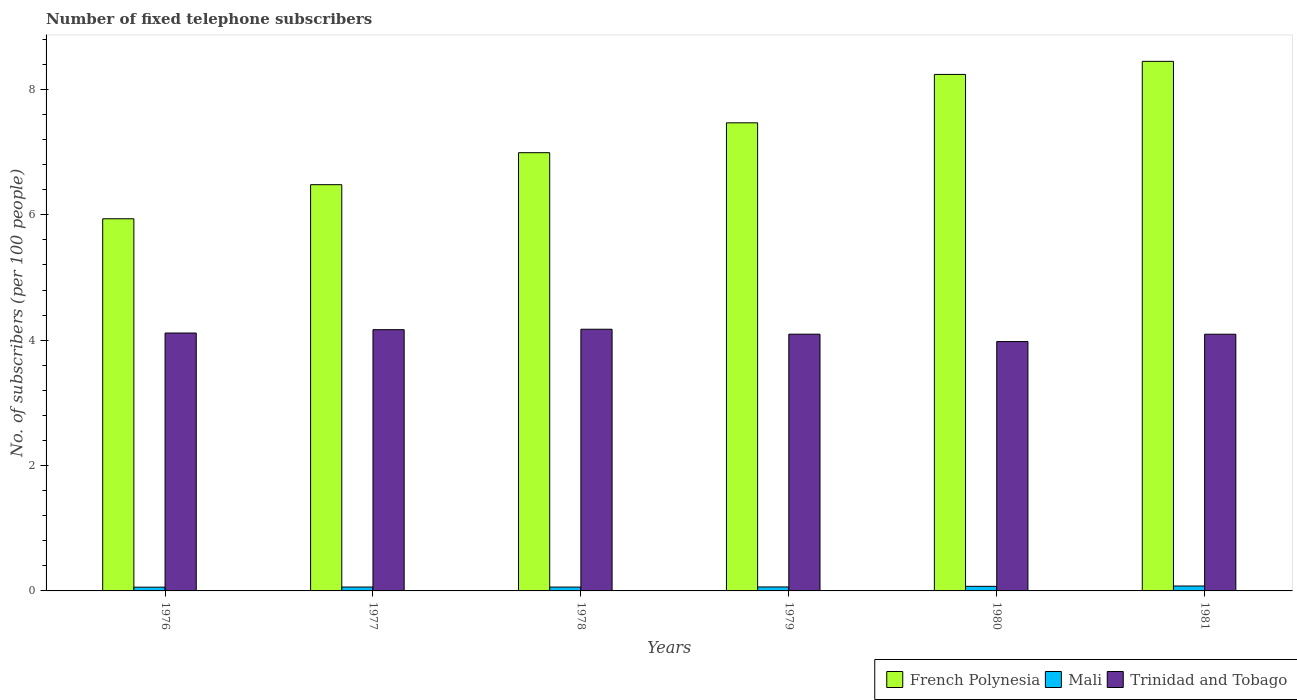How many groups of bars are there?
Your answer should be compact. 6. Are the number of bars per tick equal to the number of legend labels?
Offer a very short reply. Yes. How many bars are there on the 3rd tick from the left?
Offer a terse response. 3. What is the number of fixed telephone subscribers in Trinidad and Tobago in 1976?
Offer a very short reply. 4.11. Across all years, what is the maximum number of fixed telephone subscribers in Trinidad and Tobago?
Provide a short and direct response. 4.17. Across all years, what is the minimum number of fixed telephone subscribers in Trinidad and Tobago?
Ensure brevity in your answer.  3.98. In which year was the number of fixed telephone subscribers in French Polynesia maximum?
Provide a short and direct response. 1981. In which year was the number of fixed telephone subscribers in Mali minimum?
Give a very brief answer. 1976. What is the total number of fixed telephone subscribers in Mali in the graph?
Offer a very short reply. 0.4. What is the difference between the number of fixed telephone subscribers in French Polynesia in 1978 and that in 1979?
Offer a terse response. -0.48. What is the difference between the number of fixed telephone subscribers in Trinidad and Tobago in 1976 and the number of fixed telephone subscribers in Mali in 1980?
Provide a succinct answer. 4.04. What is the average number of fixed telephone subscribers in Trinidad and Tobago per year?
Provide a short and direct response. 4.1. In the year 1976, what is the difference between the number of fixed telephone subscribers in Trinidad and Tobago and number of fixed telephone subscribers in Mali?
Keep it short and to the point. 4.05. What is the ratio of the number of fixed telephone subscribers in Mali in 1979 to that in 1980?
Ensure brevity in your answer.  0.87. What is the difference between the highest and the second highest number of fixed telephone subscribers in Mali?
Offer a very short reply. 0.01. What is the difference between the highest and the lowest number of fixed telephone subscribers in French Polynesia?
Keep it short and to the point. 2.51. In how many years, is the number of fixed telephone subscribers in Mali greater than the average number of fixed telephone subscribers in Mali taken over all years?
Your answer should be very brief. 2. What does the 1st bar from the left in 1976 represents?
Your answer should be compact. French Polynesia. What does the 3rd bar from the right in 1977 represents?
Your response must be concise. French Polynesia. How many years are there in the graph?
Give a very brief answer. 6. Are the values on the major ticks of Y-axis written in scientific E-notation?
Offer a terse response. No. Where does the legend appear in the graph?
Provide a succinct answer. Bottom right. How are the legend labels stacked?
Give a very brief answer. Horizontal. What is the title of the graph?
Ensure brevity in your answer.  Number of fixed telephone subscribers. What is the label or title of the X-axis?
Your answer should be compact. Years. What is the label or title of the Y-axis?
Give a very brief answer. No. of subscribers (per 100 people). What is the No. of subscribers (per 100 people) of French Polynesia in 1976?
Provide a succinct answer. 5.94. What is the No. of subscribers (per 100 people) of Mali in 1976?
Provide a succinct answer. 0.06. What is the No. of subscribers (per 100 people) of Trinidad and Tobago in 1976?
Give a very brief answer. 4.11. What is the No. of subscribers (per 100 people) in French Polynesia in 1977?
Your answer should be compact. 6.48. What is the No. of subscribers (per 100 people) of Mali in 1977?
Your response must be concise. 0.06. What is the No. of subscribers (per 100 people) in Trinidad and Tobago in 1977?
Give a very brief answer. 4.17. What is the No. of subscribers (per 100 people) in French Polynesia in 1978?
Provide a short and direct response. 6.99. What is the No. of subscribers (per 100 people) of Mali in 1978?
Keep it short and to the point. 0.06. What is the No. of subscribers (per 100 people) of Trinidad and Tobago in 1978?
Give a very brief answer. 4.17. What is the No. of subscribers (per 100 people) in French Polynesia in 1979?
Your answer should be compact. 7.47. What is the No. of subscribers (per 100 people) in Mali in 1979?
Make the answer very short. 0.06. What is the No. of subscribers (per 100 people) in Trinidad and Tobago in 1979?
Offer a very short reply. 4.1. What is the No. of subscribers (per 100 people) in French Polynesia in 1980?
Your response must be concise. 8.24. What is the No. of subscribers (per 100 people) of Mali in 1980?
Make the answer very short. 0.07. What is the No. of subscribers (per 100 people) in Trinidad and Tobago in 1980?
Provide a short and direct response. 3.98. What is the No. of subscribers (per 100 people) in French Polynesia in 1981?
Make the answer very short. 8.45. What is the No. of subscribers (per 100 people) in Mali in 1981?
Your response must be concise. 0.08. What is the No. of subscribers (per 100 people) in Trinidad and Tobago in 1981?
Your answer should be very brief. 4.1. Across all years, what is the maximum No. of subscribers (per 100 people) in French Polynesia?
Provide a succinct answer. 8.45. Across all years, what is the maximum No. of subscribers (per 100 people) in Mali?
Provide a succinct answer. 0.08. Across all years, what is the maximum No. of subscribers (per 100 people) of Trinidad and Tobago?
Your answer should be compact. 4.17. Across all years, what is the minimum No. of subscribers (per 100 people) of French Polynesia?
Your response must be concise. 5.94. Across all years, what is the minimum No. of subscribers (per 100 people) of Mali?
Your answer should be compact. 0.06. Across all years, what is the minimum No. of subscribers (per 100 people) of Trinidad and Tobago?
Offer a very short reply. 3.98. What is the total No. of subscribers (per 100 people) of French Polynesia in the graph?
Your answer should be very brief. 43.57. What is the total No. of subscribers (per 100 people) of Mali in the graph?
Your response must be concise. 0.4. What is the total No. of subscribers (per 100 people) of Trinidad and Tobago in the graph?
Give a very brief answer. 24.63. What is the difference between the No. of subscribers (per 100 people) in French Polynesia in 1976 and that in 1977?
Ensure brevity in your answer.  -0.54. What is the difference between the No. of subscribers (per 100 people) of Mali in 1976 and that in 1977?
Offer a very short reply. -0. What is the difference between the No. of subscribers (per 100 people) in Trinidad and Tobago in 1976 and that in 1977?
Your answer should be compact. -0.05. What is the difference between the No. of subscribers (per 100 people) of French Polynesia in 1976 and that in 1978?
Keep it short and to the point. -1.05. What is the difference between the No. of subscribers (per 100 people) of Mali in 1976 and that in 1978?
Offer a terse response. -0. What is the difference between the No. of subscribers (per 100 people) of Trinidad and Tobago in 1976 and that in 1978?
Offer a very short reply. -0.06. What is the difference between the No. of subscribers (per 100 people) of French Polynesia in 1976 and that in 1979?
Provide a short and direct response. -1.53. What is the difference between the No. of subscribers (per 100 people) in Mali in 1976 and that in 1979?
Your answer should be very brief. -0. What is the difference between the No. of subscribers (per 100 people) in Trinidad and Tobago in 1976 and that in 1979?
Your answer should be very brief. 0.02. What is the difference between the No. of subscribers (per 100 people) of French Polynesia in 1976 and that in 1980?
Provide a short and direct response. -2.3. What is the difference between the No. of subscribers (per 100 people) in Mali in 1976 and that in 1980?
Make the answer very short. -0.01. What is the difference between the No. of subscribers (per 100 people) in Trinidad and Tobago in 1976 and that in 1980?
Your response must be concise. 0.14. What is the difference between the No. of subscribers (per 100 people) in French Polynesia in 1976 and that in 1981?
Provide a succinct answer. -2.51. What is the difference between the No. of subscribers (per 100 people) of Mali in 1976 and that in 1981?
Give a very brief answer. -0.02. What is the difference between the No. of subscribers (per 100 people) of Trinidad and Tobago in 1976 and that in 1981?
Your answer should be compact. 0.02. What is the difference between the No. of subscribers (per 100 people) in French Polynesia in 1977 and that in 1978?
Offer a very short reply. -0.51. What is the difference between the No. of subscribers (per 100 people) in Mali in 1977 and that in 1978?
Give a very brief answer. 0. What is the difference between the No. of subscribers (per 100 people) in Trinidad and Tobago in 1977 and that in 1978?
Offer a very short reply. -0.01. What is the difference between the No. of subscribers (per 100 people) in French Polynesia in 1977 and that in 1979?
Make the answer very short. -0.99. What is the difference between the No. of subscribers (per 100 people) in Mali in 1977 and that in 1979?
Provide a succinct answer. -0. What is the difference between the No. of subscribers (per 100 people) of Trinidad and Tobago in 1977 and that in 1979?
Offer a very short reply. 0.07. What is the difference between the No. of subscribers (per 100 people) in French Polynesia in 1977 and that in 1980?
Your answer should be very brief. -1.76. What is the difference between the No. of subscribers (per 100 people) in Mali in 1977 and that in 1980?
Your answer should be compact. -0.01. What is the difference between the No. of subscribers (per 100 people) of Trinidad and Tobago in 1977 and that in 1980?
Provide a short and direct response. 0.19. What is the difference between the No. of subscribers (per 100 people) in French Polynesia in 1977 and that in 1981?
Offer a terse response. -1.97. What is the difference between the No. of subscribers (per 100 people) of Mali in 1977 and that in 1981?
Keep it short and to the point. -0.02. What is the difference between the No. of subscribers (per 100 people) in Trinidad and Tobago in 1977 and that in 1981?
Offer a very short reply. 0.07. What is the difference between the No. of subscribers (per 100 people) of French Polynesia in 1978 and that in 1979?
Give a very brief answer. -0.48. What is the difference between the No. of subscribers (per 100 people) in Mali in 1978 and that in 1979?
Your response must be concise. -0. What is the difference between the No. of subscribers (per 100 people) of Trinidad and Tobago in 1978 and that in 1979?
Offer a terse response. 0.08. What is the difference between the No. of subscribers (per 100 people) of French Polynesia in 1978 and that in 1980?
Your answer should be compact. -1.25. What is the difference between the No. of subscribers (per 100 people) of Mali in 1978 and that in 1980?
Offer a terse response. -0.01. What is the difference between the No. of subscribers (per 100 people) in Trinidad and Tobago in 1978 and that in 1980?
Your response must be concise. 0.2. What is the difference between the No. of subscribers (per 100 people) in French Polynesia in 1978 and that in 1981?
Ensure brevity in your answer.  -1.46. What is the difference between the No. of subscribers (per 100 people) of Mali in 1978 and that in 1981?
Provide a short and direct response. -0.02. What is the difference between the No. of subscribers (per 100 people) in Trinidad and Tobago in 1978 and that in 1981?
Keep it short and to the point. 0.08. What is the difference between the No. of subscribers (per 100 people) of French Polynesia in 1979 and that in 1980?
Make the answer very short. -0.77. What is the difference between the No. of subscribers (per 100 people) in Mali in 1979 and that in 1980?
Your answer should be compact. -0.01. What is the difference between the No. of subscribers (per 100 people) in Trinidad and Tobago in 1979 and that in 1980?
Make the answer very short. 0.12. What is the difference between the No. of subscribers (per 100 people) in French Polynesia in 1979 and that in 1981?
Ensure brevity in your answer.  -0.98. What is the difference between the No. of subscribers (per 100 people) of Mali in 1979 and that in 1981?
Keep it short and to the point. -0.02. What is the difference between the No. of subscribers (per 100 people) in Trinidad and Tobago in 1979 and that in 1981?
Ensure brevity in your answer.  0. What is the difference between the No. of subscribers (per 100 people) of French Polynesia in 1980 and that in 1981?
Give a very brief answer. -0.21. What is the difference between the No. of subscribers (per 100 people) in Mali in 1980 and that in 1981?
Offer a terse response. -0.01. What is the difference between the No. of subscribers (per 100 people) in Trinidad and Tobago in 1980 and that in 1981?
Provide a short and direct response. -0.12. What is the difference between the No. of subscribers (per 100 people) of French Polynesia in 1976 and the No. of subscribers (per 100 people) of Mali in 1977?
Offer a very short reply. 5.88. What is the difference between the No. of subscribers (per 100 people) of French Polynesia in 1976 and the No. of subscribers (per 100 people) of Trinidad and Tobago in 1977?
Your answer should be very brief. 1.77. What is the difference between the No. of subscribers (per 100 people) in Mali in 1976 and the No. of subscribers (per 100 people) in Trinidad and Tobago in 1977?
Keep it short and to the point. -4.11. What is the difference between the No. of subscribers (per 100 people) in French Polynesia in 1976 and the No. of subscribers (per 100 people) in Mali in 1978?
Offer a terse response. 5.88. What is the difference between the No. of subscribers (per 100 people) of French Polynesia in 1976 and the No. of subscribers (per 100 people) of Trinidad and Tobago in 1978?
Give a very brief answer. 1.76. What is the difference between the No. of subscribers (per 100 people) in Mali in 1976 and the No. of subscribers (per 100 people) in Trinidad and Tobago in 1978?
Keep it short and to the point. -4.11. What is the difference between the No. of subscribers (per 100 people) in French Polynesia in 1976 and the No. of subscribers (per 100 people) in Mali in 1979?
Give a very brief answer. 5.87. What is the difference between the No. of subscribers (per 100 people) in French Polynesia in 1976 and the No. of subscribers (per 100 people) in Trinidad and Tobago in 1979?
Give a very brief answer. 1.84. What is the difference between the No. of subscribers (per 100 people) in Mali in 1976 and the No. of subscribers (per 100 people) in Trinidad and Tobago in 1979?
Keep it short and to the point. -4.04. What is the difference between the No. of subscribers (per 100 people) in French Polynesia in 1976 and the No. of subscribers (per 100 people) in Mali in 1980?
Make the answer very short. 5.86. What is the difference between the No. of subscribers (per 100 people) in French Polynesia in 1976 and the No. of subscribers (per 100 people) in Trinidad and Tobago in 1980?
Ensure brevity in your answer.  1.96. What is the difference between the No. of subscribers (per 100 people) in Mali in 1976 and the No. of subscribers (per 100 people) in Trinidad and Tobago in 1980?
Make the answer very short. -3.92. What is the difference between the No. of subscribers (per 100 people) in French Polynesia in 1976 and the No. of subscribers (per 100 people) in Mali in 1981?
Provide a succinct answer. 5.86. What is the difference between the No. of subscribers (per 100 people) of French Polynesia in 1976 and the No. of subscribers (per 100 people) of Trinidad and Tobago in 1981?
Your answer should be very brief. 1.84. What is the difference between the No. of subscribers (per 100 people) of Mali in 1976 and the No. of subscribers (per 100 people) of Trinidad and Tobago in 1981?
Your response must be concise. -4.04. What is the difference between the No. of subscribers (per 100 people) of French Polynesia in 1977 and the No. of subscribers (per 100 people) of Mali in 1978?
Provide a short and direct response. 6.42. What is the difference between the No. of subscribers (per 100 people) of French Polynesia in 1977 and the No. of subscribers (per 100 people) of Trinidad and Tobago in 1978?
Your answer should be compact. 2.31. What is the difference between the No. of subscribers (per 100 people) in Mali in 1977 and the No. of subscribers (per 100 people) in Trinidad and Tobago in 1978?
Your answer should be compact. -4.11. What is the difference between the No. of subscribers (per 100 people) of French Polynesia in 1977 and the No. of subscribers (per 100 people) of Mali in 1979?
Keep it short and to the point. 6.42. What is the difference between the No. of subscribers (per 100 people) of French Polynesia in 1977 and the No. of subscribers (per 100 people) of Trinidad and Tobago in 1979?
Your answer should be compact. 2.39. What is the difference between the No. of subscribers (per 100 people) of Mali in 1977 and the No. of subscribers (per 100 people) of Trinidad and Tobago in 1979?
Your answer should be very brief. -4.03. What is the difference between the No. of subscribers (per 100 people) of French Polynesia in 1977 and the No. of subscribers (per 100 people) of Mali in 1980?
Your response must be concise. 6.41. What is the difference between the No. of subscribers (per 100 people) in French Polynesia in 1977 and the No. of subscribers (per 100 people) in Trinidad and Tobago in 1980?
Your answer should be very brief. 2.5. What is the difference between the No. of subscribers (per 100 people) of Mali in 1977 and the No. of subscribers (per 100 people) of Trinidad and Tobago in 1980?
Your response must be concise. -3.92. What is the difference between the No. of subscribers (per 100 people) in French Polynesia in 1977 and the No. of subscribers (per 100 people) in Mali in 1981?
Offer a terse response. 6.4. What is the difference between the No. of subscribers (per 100 people) of French Polynesia in 1977 and the No. of subscribers (per 100 people) of Trinidad and Tobago in 1981?
Your answer should be very brief. 2.39. What is the difference between the No. of subscribers (per 100 people) of Mali in 1977 and the No. of subscribers (per 100 people) of Trinidad and Tobago in 1981?
Your answer should be very brief. -4.03. What is the difference between the No. of subscribers (per 100 people) of French Polynesia in 1978 and the No. of subscribers (per 100 people) of Mali in 1979?
Your response must be concise. 6.93. What is the difference between the No. of subscribers (per 100 people) of French Polynesia in 1978 and the No. of subscribers (per 100 people) of Trinidad and Tobago in 1979?
Ensure brevity in your answer.  2.9. What is the difference between the No. of subscribers (per 100 people) of Mali in 1978 and the No. of subscribers (per 100 people) of Trinidad and Tobago in 1979?
Provide a short and direct response. -4.03. What is the difference between the No. of subscribers (per 100 people) of French Polynesia in 1978 and the No. of subscribers (per 100 people) of Mali in 1980?
Provide a short and direct response. 6.92. What is the difference between the No. of subscribers (per 100 people) of French Polynesia in 1978 and the No. of subscribers (per 100 people) of Trinidad and Tobago in 1980?
Provide a succinct answer. 3.01. What is the difference between the No. of subscribers (per 100 people) in Mali in 1978 and the No. of subscribers (per 100 people) in Trinidad and Tobago in 1980?
Provide a short and direct response. -3.92. What is the difference between the No. of subscribers (per 100 people) in French Polynesia in 1978 and the No. of subscribers (per 100 people) in Mali in 1981?
Keep it short and to the point. 6.91. What is the difference between the No. of subscribers (per 100 people) in French Polynesia in 1978 and the No. of subscribers (per 100 people) in Trinidad and Tobago in 1981?
Provide a succinct answer. 2.9. What is the difference between the No. of subscribers (per 100 people) in Mali in 1978 and the No. of subscribers (per 100 people) in Trinidad and Tobago in 1981?
Give a very brief answer. -4.03. What is the difference between the No. of subscribers (per 100 people) in French Polynesia in 1979 and the No. of subscribers (per 100 people) in Mali in 1980?
Make the answer very short. 7.39. What is the difference between the No. of subscribers (per 100 people) of French Polynesia in 1979 and the No. of subscribers (per 100 people) of Trinidad and Tobago in 1980?
Offer a terse response. 3.49. What is the difference between the No. of subscribers (per 100 people) of Mali in 1979 and the No. of subscribers (per 100 people) of Trinidad and Tobago in 1980?
Ensure brevity in your answer.  -3.91. What is the difference between the No. of subscribers (per 100 people) of French Polynesia in 1979 and the No. of subscribers (per 100 people) of Mali in 1981?
Give a very brief answer. 7.39. What is the difference between the No. of subscribers (per 100 people) of French Polynesia in 1979 and the No. of subscribers (per 100 people) of Trinidad and Tobago in 1981?
Your answer should be very brief. 3.37. What is the difference between the No. of subscribers (per 100 people) of Mali in 1979 and the No. of subscribers (per 100 people) of Trinidad and Tobago in 1981?
Provide a succinct answer. -4.03. What is the difference between the No. of subscribers (per 100 people) in French Polynesia in 1980 and the No. of subscribers (per 100 people) in Mali in 1981?
Your answer should be very brief. 8.16. What is the difference between the No. of subscribers (per 100 people) of French Polynesia in 1980 and the No. of subscribers (per 100 people) of Trinidad and Tobago in 1981?
Make the answer very short. 4.14. What is the difference between the No. of subscribers (per 100 people) in Mali in 1980 and the No. of subscribers (per 100 people) in Trinidad and Tobago in 1981?
Offer a terse response. -4.02. What is the average No. of subscribers (per 100 people) of French Polynesia per year?
Your answer should be very brief. 7.26. What is the average No. of subscribers (per 100 people) of Mali per year?
Offer a terse response. 0.07. What is the average No. of subscribers (per 100 people) of Trinidad and Tobago per year?
Ensure brevity in your answer.  4.1. In the year 1976, what is the difference between the No. of subscribers (per 100 people) in French Polynesia and No. of subscribers (per 100 people) in Mali?
Offer a terse response. 5.88. In the year 1976, what is the difference between the No. of subscribers (per 100 people) of French Polynesia and No. of subscribers (per 100 people) of Trinidad and Tobago?
Make the answer very short. 1.82. In the year 1976, what is the difference between the No. of subscribers (per 100 people) in Mali and No. of subscribers (per 100 people) in Trinidad and Tobago?
Provide a succinct answer. -4.05. In the year 1977, what is the difference between the No. of subscribers (per 100 people) in French Polynesia and No. of subscribers (per 100 people) in Mali?
Ensure brevity in your answer.  6.42. In the year 1977, what is the difference between the No. of subscribers (per 100 people) of French Polynesia and No. of subscribers (per 100 people) of Trinidad and Tobago?
Ensure brevity in your answer.  2.31. In the year 1977, what is the difference between the No. of subscribers (per 100 people) of Mali and No. of subscribers (per 100 people) of Trinidad and Tobago?
Ensure brevity in your answer.  -4.11. In the year 1978, what is the difference between the No. of subscribers (per 100 people) in French Polynesia and No. of subscribers (per 100 people) in Mali?
Your answer should be very brief. 6.93. In the year 1978, what is the difference between the No. of subscribers (per 100 people) in French Polynesia and No. of subscribers (per 100 people) in Trinidad and Tobago?
Your answer should be very brief. 2.82. In the year 1978, what is the difference between the No. of subscribers (per 100 people) in Mali and No. of subscribers (per 100 people) in Trinidad and Tobago?
Your answer should be compact. -4.11. In the year 1979, what is the difference between the No. of subscribers (per 100 people) in French Polynesia and No. of subscribers (per 100 people) in Mali?
Offer a very short reply. 7.4. In the year 1979, what is the difference between the No. of subscribers (per 100 people) in French Polynesia and No. of subscribers (per 100 people) in Trinidad and Tobago?
Provide a succinct answer. 3.37. In the year 1979, what is the difference between the No. of subscribers (per 100 people) in Mali and No. of subscribers (per 100 people) in Trinidad and Tobago?
Provide a succinct answer. -4.03. In the year 1980, what is the difference between the No. of subscribers (per 100 people) in French Polynesia and No. of subscribers (per 100 people) in Mali?
Give a very brief answer. 8.17. In the year 1980, what is the difference between the No. of subscribers (per 100 people) of French Polynesia and No. of subscribers (per 100 people) of Trinidad and Tobago?
Offer a terse response. 4.26. In the year 1980, what is the difference between the No. of subscribers (per 100 people) of Mali and No. of subscribers (per 100 people) of Trinidad and Tobago?
Your answer should be compact. -3.9. In the year 1981, what is the difference between the No. of subscribers (per 100 people) in French Polynesia and No. of subscribers (per 100 people) in Mali?
Your response must be concise. 8.37. In the year 1981, what is the difference between the No. of subscribers (per 100 people) in French Polynesia and No. of subscribers (per 100 people) in Trinidad and Tobago?
Offer a terse response. 4.35. In the year 1981, what is the difference between the No. of subscribers (per 100 people) of Mali and No. of subscribers (per 100 people) of Trinidad and Tobago?
Your answer should be compact. -4.02. What is the ratio of the No. of subscribers (per 100 people) in French Polynesia in 1976 to that in 1977?
Offer a terse response. 0.92. What is the ratio of the No. of subscribers (per 100 people) in Mali in 1976 to that in 1977?
Keep it short and to the point. 0.97. What is the ratio of the No. of subscribers (per 100 people) in Trinidad and Tobago in 1976 to that in 1977?
Offer a very short reply. 0.99. What is the ratio of the No. of subscribers (per 100 people) in French Polynesia in 1976 to that in 1978?
Give a very brief answer. 0.85. What is the ratio of the No. of subscribers (per 100 people) in Mali in 1976 to that in 1978?
Provide a succinct answer. 0.98. What is the ratio of the No. of subscribers (per 100 people) of Trinidad and Tobago in 1976 to that in 1978?
Your response must be concise. 0.99. What is the ratio of the No. of subscribers (per 100 people) in French Polynesia in 1976 to that in 1979?
Ensure brevity in your answer.  0.8. What is the ratio of the No. of subscribers (per 100 people) in Mali in 1976 to that in 1979?
Make the answer very short. 0.95. What is the ratio of the No. of subscribers (per 100 people) of Trinidad and Tobago in 1976 to that in 1979?
Offer a very short reply. 1. What is the ratio of the No. of subscribers (per 100 people) of French Polynesia in 1976 to that in 1980?
Your response must be concise. 0.72. What is the ratio of the No. of subscribers (per 100 people) of Mali in 1976 to that in 1980?
Offer a very short reply. 0.82. What is the ratio of the No. of subscribers (per 100 people) in Trinidad and Tobago in 1976 to that in 1980?
Make the answer very short. 1.03. What is the ratio of the No. of subscribers (per 100 people) in French Polynesia in 1976 to that in 1981?
Ensure brevity in your answer.  0.7. What is the ratio of the No. of subscribers (per 100 people) in Mali in 1976 to that in 1981?
Keep it short and to the point. 0.76. What is the ratio of the No. of subscribers (per 100 people) of Trinidad and Tobago in 1976 to that in 1981?
Ensure brevity in your answer.  1. What is the ratio of the No. of subscribers (per 100 people) in French Polynesia in 1977 to that in 1978?
Your answer should be very brief. 0.93. What is the ratio of the No. of subscribers (per 100 people) of Mali in 1977 to that in 1978?
Offer a terse response. 1.01. What is the ratio of the No. of subscribers (per 100 people) of Trinidad and Tobago in 1977 to that in 1978?
Ensure brevity in your answer.  1. What is the ratio of the No. of subscribers (per 100 people) in French Polynesia in 1977 to that in 1979?
Provide a succinct answer. 0.87. What is the ratio of the No. of subscribers (per 100 people) in Mali in 1977 to that in 1979?
Your answer should be very brief. 0.98. What is the ratio of the No. of subscribers (per 100 people) of Trinidad and Tobago in 1977 to that in 1979?
Ensure brevity in your answer.  1.02. What is the ratio of the No. of subscribers (per 100 people) of French Polynesia in 1977 to that in 1980?
Offer a very short reply. 0.79. What is the ratio of the No. of subscribers (per 100 people) in Mali in 1977 to that in 1980?
Offer a terse response. 0.85. What is the ratio of the No. of subscribers (per 100 people) of Trinidad and Tobago in 1977 to that in 1980?
Make the answer very short. 1.05. What is the ratio of the No. of subscribers (per 100 people) of French Polynesia in 1977 to that in 1981?
Keep it short and to the point. 0.77. What is the ratio of the No. of subscribers (per 100 people) of Mali in 1977 to that in 1981?
Your answer should be compact. 0.79. What is the ratio of the No. of subscribers (per 100 people) in Trinidad and Tobago in 1977 to that in 1981?
Your response must be concise. 1.02. What is the ratio of the No. of subscribers (per 100 people) in French Polynesia in 1978 to that in 1979?
Give a very brief answer. 0.94. What is the ratio of the No. of subscribers (per 100 people) of Mali in 1978 to that in 1979?
Give a very brief answer. 0.97. What is the ratio of the No. of subscribers (per 100 people) of Trinidad and Tobago in 1978 to that in 1979?
Make the answer very short. 1.02. What is the ratio of the No. of subscribers (per 100 people) in French Polynesia in 1978 to that in 1980?
Provide a short and direct response. 0.85. What is the ratio of the No. of subscribers (per 100 people) in Mali in 1978 to that in 1980?
Offer a terse response. 0.84. What is the ratio of the No. of subscribers (per 100 people) of Trinidad and Tobago in 1978 to that in 1980?
Provide a short and direct response. 1.05. What is the ratio of the No. of subscribers (per 100 people) of French Polynesia in 1978 to that in 1981?
Your answer should be compact. 0.83. What is the ratio of the No. of subscribers (per 100 people) in Mali in 1978 to that in 1981?
Provide a short and direct response. 0.78. What is the ratio of the No. of subscribers (per 100 people) of Trinidad and Tobago in 1978 to that in 1981?
Your answer should be compact. 1.02. What is the ratio of the No. of subscribers (per 100 people) in French Polynesia in 1979 to that in 1980?
Provide a succinct answer. 0.91. What is the ratio of the No. of subscribers (per 100 people) in Mali in 1979 to that in 1980?
Offer a very short reply. 0.87. What is the ratio of the No. of subscribers (per 100 people) in Trinidad and Tobago in 1979 to that in 1980?
Offer a very short reply. 1.03. What is the ratio of the No. of subscribers (per 100 people) of French Polynesia in 1979 to that in 1981?
Your answer should be very brief. 0.88. What is the ratio of the No. of subscribers (per 100 people) of Mali in 1979 to that in 1981?
Your answer should be very brief. 0.81. What is the ratio of the No. of subscribers (per 100 people) of Trinidad and Tobago in 1979 to that in 1981?
Offer a very short reply. 1. What is the ratio of the No. of subscribers (per 100 people) in French Polynesia in 1980 to that in 1981?
Your answer should be compact. 0.98. What is the ratio of the No. of subscribers (per 100 people) of Mali in 1980 to that in 1981?
Provide a succinct answer. 0.93. What is the ratio of the No. of subscribers (per 100 people) in Trinidad and Tobago in 1980 to that in 1981?
Make the answer very short. 0.97. What is the difference between the highest and the second highest No. of subscribers (per 100 people) of French Polynesia?
Make the answer very short. 0.21. What is the difference between the highest and the second highest No. of subscribers (per 100 people) in Mali?
Make the answer very short. 0.01. What is the difference between the highest and the second highest No. of subscribers (per 100 people) in Trinidad and Tobago?
Provide a succinct answer. 0.01. What is the difference between the highest and the lowest No. of subscribers (per 100 people) of French Polynesia?
Offer a terse response. 2.51. What is the difference between the highest and the lowest No. of subscribers (per 100 people) of Mali?
Make the answer very short. 0.02. What is the difference between the highest and the lowest No. of subscribers (per 100 people) in Trinidad and Tobago?
Keep it short and to the point. 0.2. 